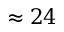Convert formula to latex. <formula><loc_0><loc_0><loc_500><loc_500>\approx 2 4</formula> 